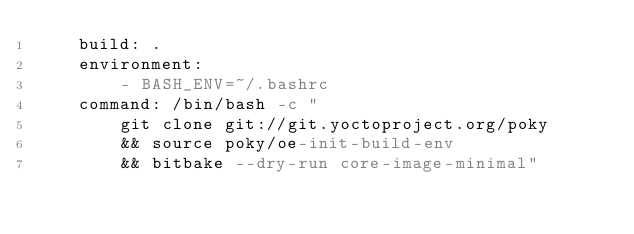<code> <loc_0><loc_0><loc_500><loc_500><_YAML_>    build: .
    environment:
        - BASH_ENV=~/.bashrc
    command: /bin/bash -c "
        git clone git://git.yoctoproject.org/poky
        && source poky/oe-init-build-env
        && bitbake --dry-run core-image-minimal" 
</code> 